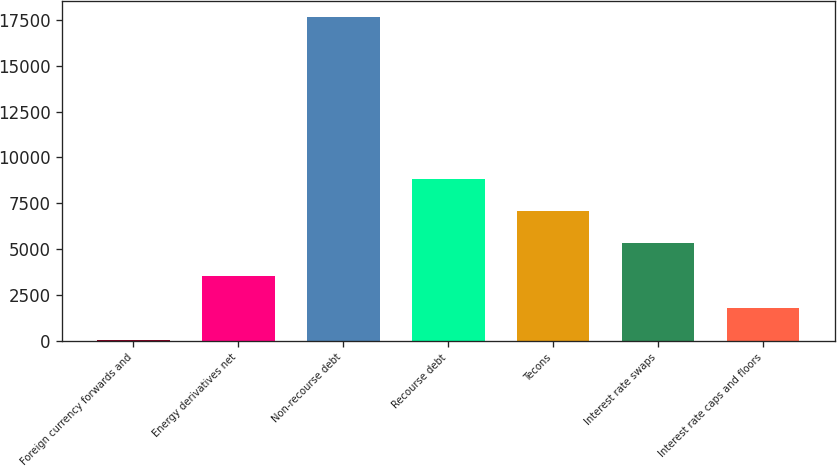Convert chart to OTSL. <chart><loc_0><loc_0><loc_500><loc_500><bar_chart><fcel>Foreign currency forwards and<fcel>Energy derivatives net<fcel>Non-recourse debt<fcel>Recourse debt<fcel>Tecons<fcel>Interest rate swaps<fcel>Interest rate caps and floors<nl><fcel>17<fcel>3545.2<fcel>17658<fcel>8837.5<fcel>7073.4<fcel>5309.3<fcel>1781.1<nl></chart> 